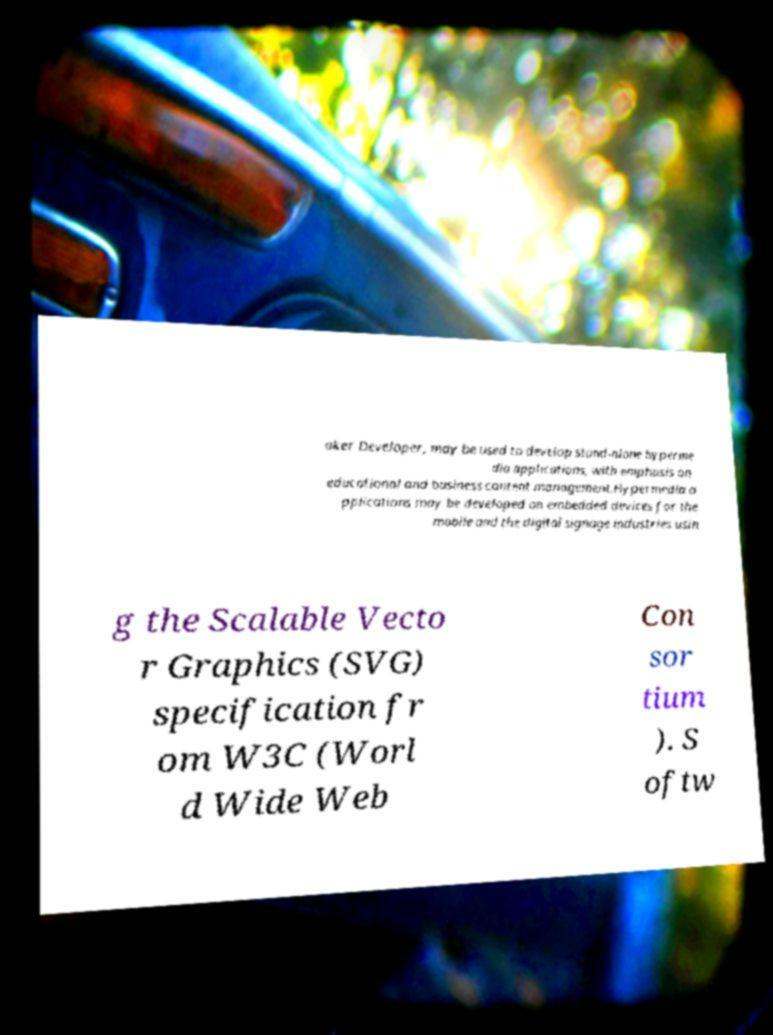Can you read and provide the text displayed in the image?This photo seems to have some interesting text. Can you extract and type it out for me? aker Developer, may be used to develop stand-alone hyperme dia applications, with emphasis on educational and business content management.Hypermedia a pplications may be developed on embedded devices for the mobile and the digital signage industries usin g the Scalable Vecto r Graphics (SVG) specification fr om W3C (Worl d Wide Web Con sor tium ). S oftw 